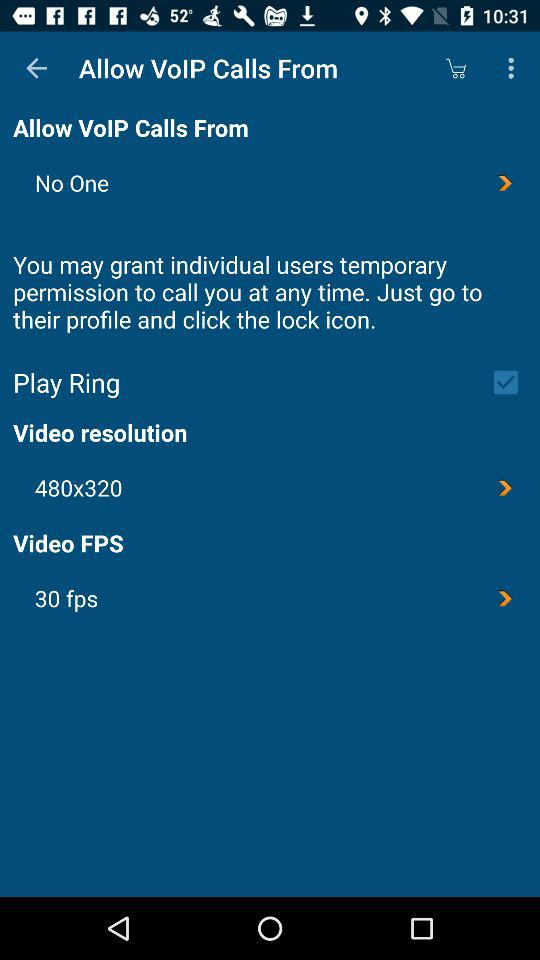What is the video FPS? The video FPS is 30. 